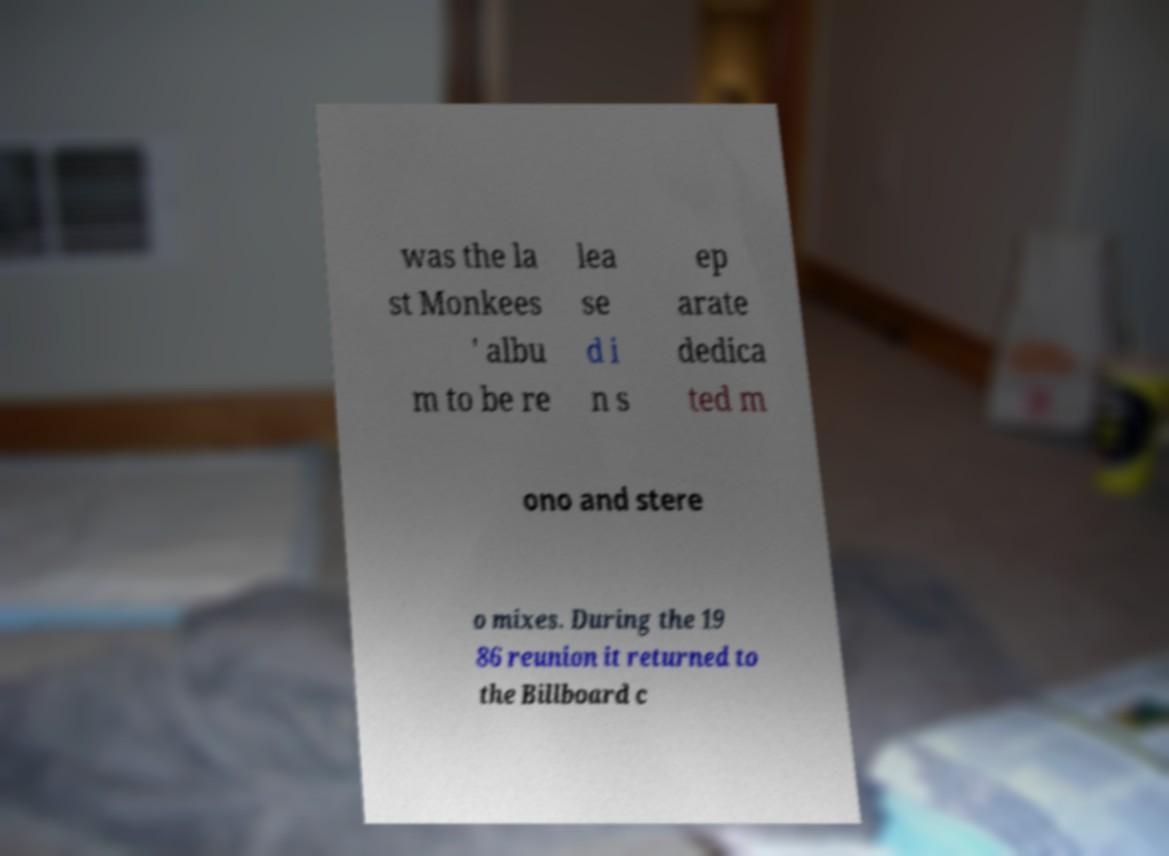For documentation purposes, I need the text within this image transcribed. Could you provide that? was the la st Monkees ' albu m to be re lea se d i n s ep arate dedica ted m ono and stere o mixes. During the 19 86 reunion it returned to the Billboard c 